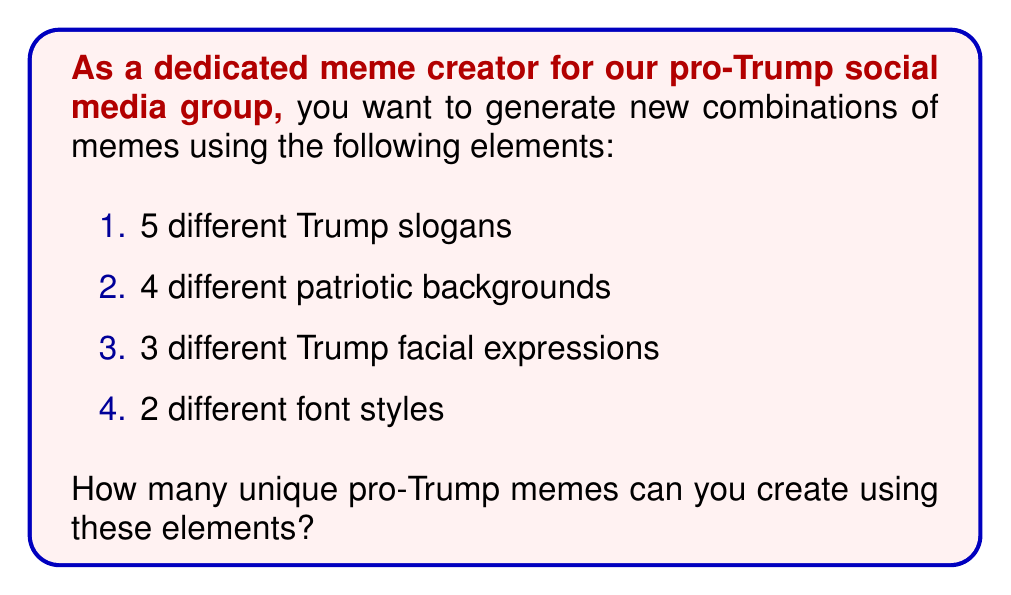Can you solve this math problem? Let's approach this step-by-step using the multiplication principle of counting:

1) For each meme, we need to choose:
   - One slogan out of 5
   - One background out of 4
   - One Trump facial expression out of 3
   - One font style out of 2

2) According to the multiplication principle, if we have a series of independent choices, the total number of possible outcomes is the product of the number of possibilities for each choice.

3) Therefore, the total number of unique memes is:

   $$5 \times 4 \times 3 \times 2$$

4) Let's calculate this:
   $$5 \times 4 \times 3 \times 2 = 20 \times 3 \times 2 = 60 \times 2 = 120$$

Thus, you can create 120 unique pro-Trump memes using the given elements.
Answer: 120 unique memes 